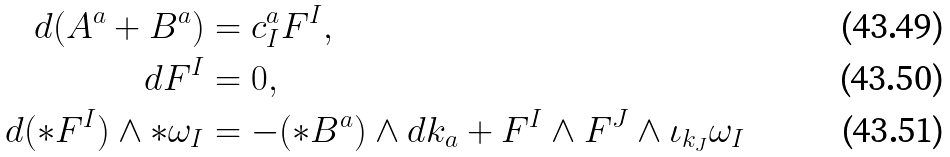<formula> <loc_0><loc_0><loc_500><loc_500>d ( A ^ { a } + B ^ { a } ) & = c ^ { a } _ { I } F ^ { I } , \\ d F ^ { I } & = 0 , \\ d ( * F ^ { I } ) \wedge * \omega _ { I } & = - ( * B ^ { a } ) \wedge d k _ { a } + F ^ { I } \wedge F ^ { J } \wedge \iota _ { k _ { J } } \omega _ { I }</formula> 